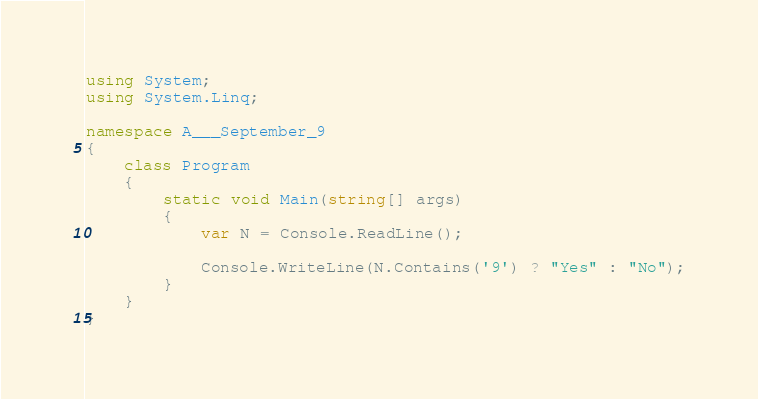Convert code to text. <code><loc_0><loc_0><loc_500><loc_500><_C#_>using System;
using System.Linq;

namespace A___September_9
{
    class Program
    {
        static void Main(string[] args)
        {
            var N = Console.ReadLine();

            Console.WriteLine(N.Contains('9') ? "Yes" : "No");
        }
    }
}
</code> 